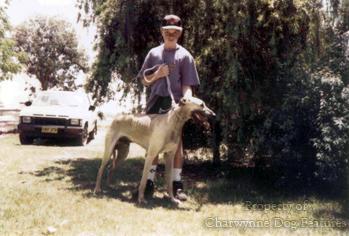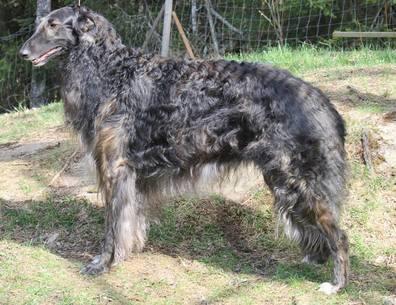The first image is the image on the left, the second image is the image on the right. For the images displayed, is the sentence "All hounds are standing, and one image contains one rightward facing hound on a leash." factually correct? Answer yes or no. Yes. The first image is the image on the left, the second image is the image on the right. Analyze the images presented: Is the assertion "The left image contains exactly two dogs." valid? Answer yes or no. No. 